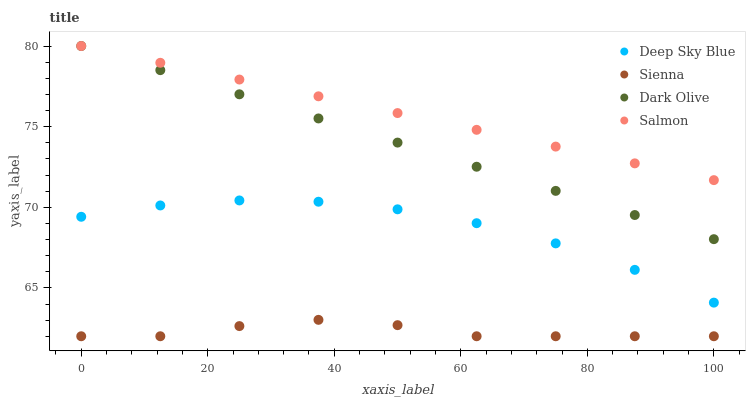Does Sienna have the minimum area under the curve?
Answer yes or no. Yes. Does Salmon have the maximum area under the curve?
Answer yes or no. Yes. Does Dark Olive have the minimum area under the curve?
Answer yes or no. No. Does Dark Olive have the maximum area under the curve?
Answer yes or no. No. Is Salmon the smoothest?
Answer yes or no. Yes. Is Deep Sky Blue the roughest?
Answer yes or no. Yes. Is Dark Olive the smoothest?
Answer yes or no. No. Is Dark Olive the roughest?
Answer yes or no. No. Does Sienna have the lowest value?
Answer yes or no. Yes. Does Dark Olive have the lowest value?
Answer yes or no. No. Does Salmon have the highest value?
Answer yes or no. Yes. Does Deep Sky Blue have the highest value?
Answer yes or no. No. Is Sienna less than Salmon?
Answer yes or no. Yes. Is Dark Olive greater than Deep Sky Blue?
Answer yes or no. Yes. Does Dark Olive intersect Salmon?
Answer yes or no. Yes. Is Dark Olive less than Salmon?
Answer yes or no. No. Is Dark Olive greater than Salmon?
Answer yes or no. No. Does Sienna intersect Salmon?
Answer yes or no. No. 